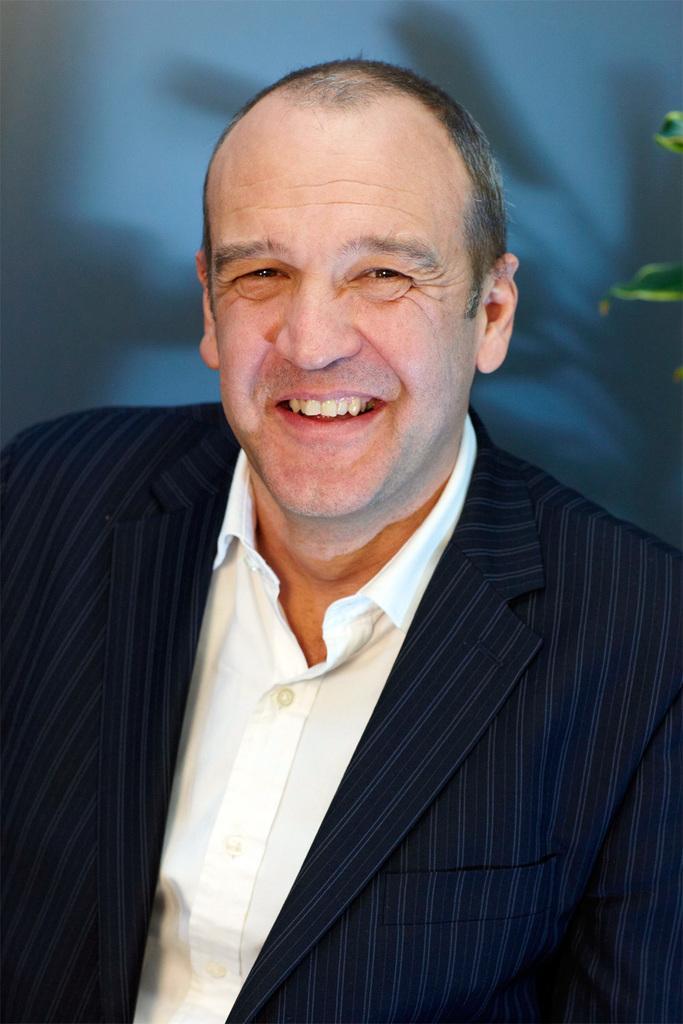Describe this image in one or two sentences. In this image I see a man who is wearing a suit and a white shirt in it and the man is smiling. 